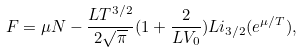Convert formula to latex. <formula><loc_0><loc_0><loc_500><loc_500>F = \mu { N } - \frac { L T ^ { 3 / 2 } } { 2 \sqrt { \pi } } ( 1 + \frac { 2 } { L V _ { 0 } } ) L i _ { 3 / 2 } ( e ^ { \mu / T } ) ,</formula> 